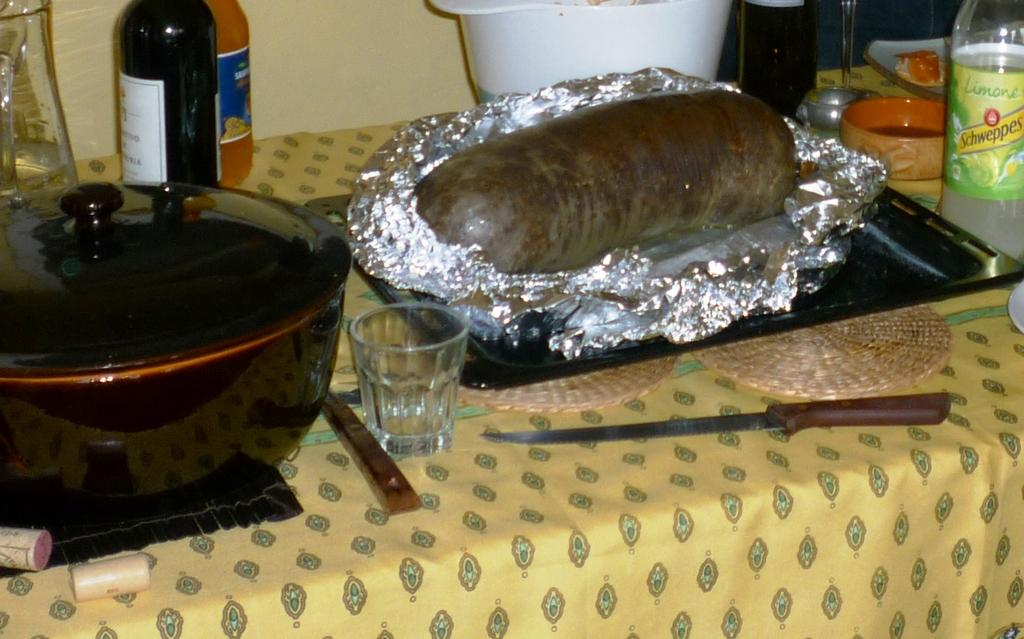<image>
Provide a brief description of the given image. A bottle of Schweppes is on a table next to a foil wrapped food loaf and a pot. 